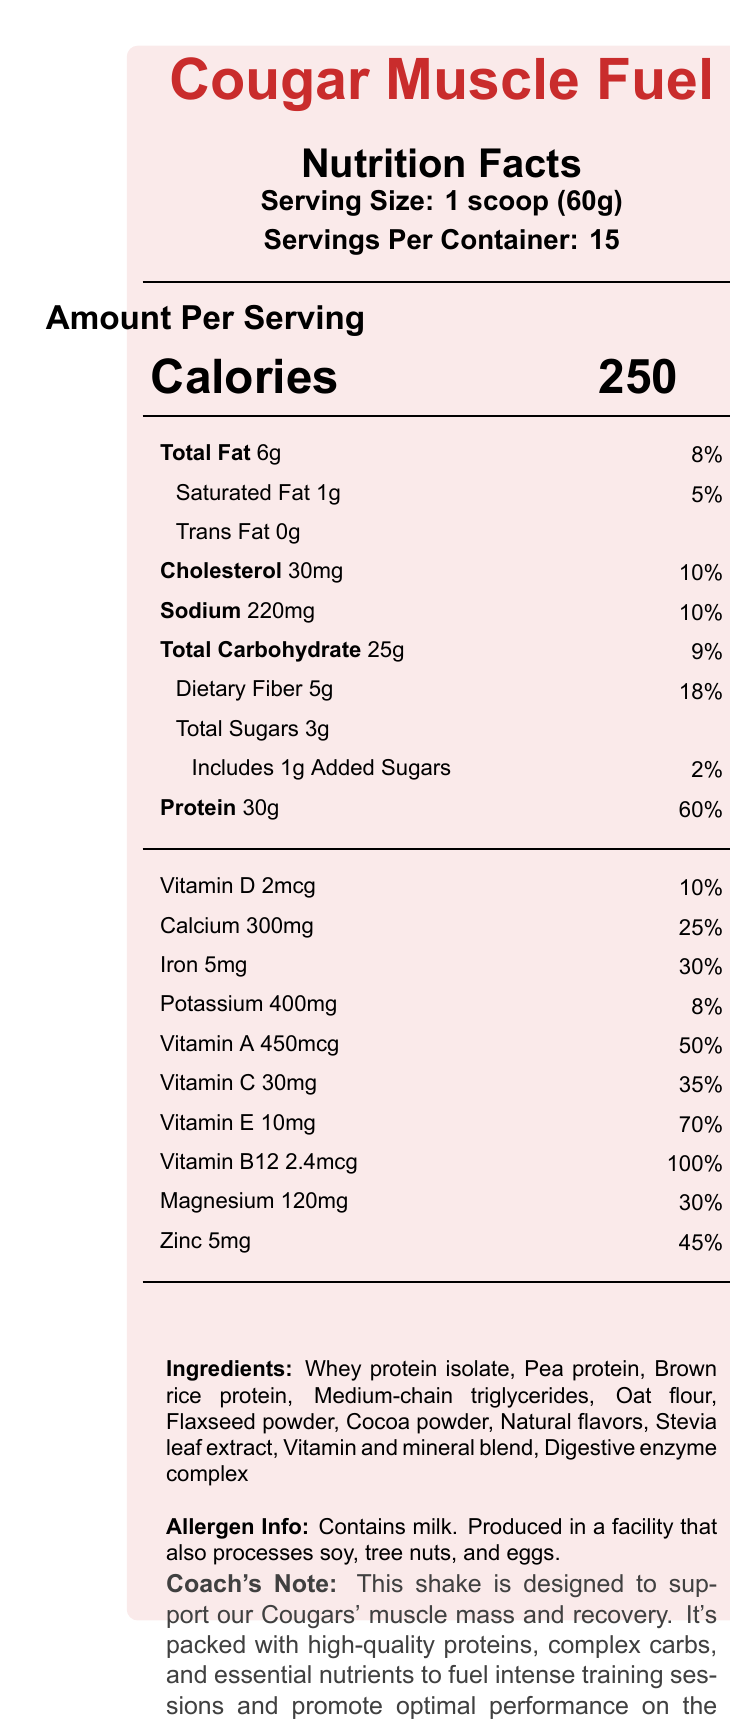what is the serving size? The serving size is listed as "1 scoop (60g)" in the document.
Answer: 1 scoop (60g) how many servings are there per container? The document states there are 15 servings per container.
Answer: 15 how many calories are in one serving? The document clearly shows that one serving contains 250 calories.
Answer: 250 how much protein is in each serving? According to the document, each serving contains 30g of protein.
Answer: 30g what is the amount of dietary fiber per serving? The document lists dietary fiber as 5g per serving.
Answer: 5g how much total fat is in one serving? A. 2g B. 4g C. 6g D. 8g The document states total fat content per serving is 6g.
Answer: C what is the daily value percentage for vitamin B12 per serving? A. 50% B. 70% C. 100% D. 120% The document indicates that the daily value percentage for vitamin B12 is 100%.
Answer: C is there any trans fat in this meal replacement shake? The document states there is 0g of trans fat.
Answer: No does this product contain any allergens? The document mentions it contains milk and is produced in a facility that processes soy, tree nuts, and eggs.
Answer: Yes how many grams of added sugars does this shake include? The document specifies there is 1g of added sugars per serving.
Answer: 1g what is the main purpose of this shake according to the coach's note? The coach's note specifies the shake is designed to support muscle mass and recovery and to fuel intense training sessions and promote optimal performance on the field.
Answer: To support muscle mass and recovery and fuel intense training sessions summarize the nutritional information displayed in the document The document contains detailed information about serving size, calories, fats, carbohydrates, protein, vitamins, and minerals, along with the ingredients and allergen information. The coach's note emphasizes its purpose for muscle mass and recovery.
Answer: The document provides the nutritional facts of Cougar Muscle Fuel, a nutrient-dense meal replacement shake designed to maintain muscle mass. Each serving (60g) contains 250 calories, 6g of fat, 30g of protein, and an array of vitamins and minerals with high daily values. The shake includes ingredients intended to support intense training and recovery while being allergen-aware. what is the magnesium content in one serving? The document shows the magnesium content is 120mg per serving.
Answer: 120mg which protein sources are included in this shake? The document lists three protein sources: Whey protein isolate, Pea protein, and Brown rice protein.
Answer: Whey protein isolate, Pea protein, Brown rice protein can this document tell us if the shake is suitable for vegans? The document mentions it contains milk, but does not provide sufficient information to determine overall suitability for vegans.
Answer: Cannot be determined what is the daily value percentage of iron provided in each serving? The document shows that the iron content per serving provides 30% of the daily value.
Answer: 30% what is the sodium content per serving and its daily value percentage? The document states that each serving contains 220mg of sodium, which is 10% of the daily value.
Answer: 220mg, 10% 